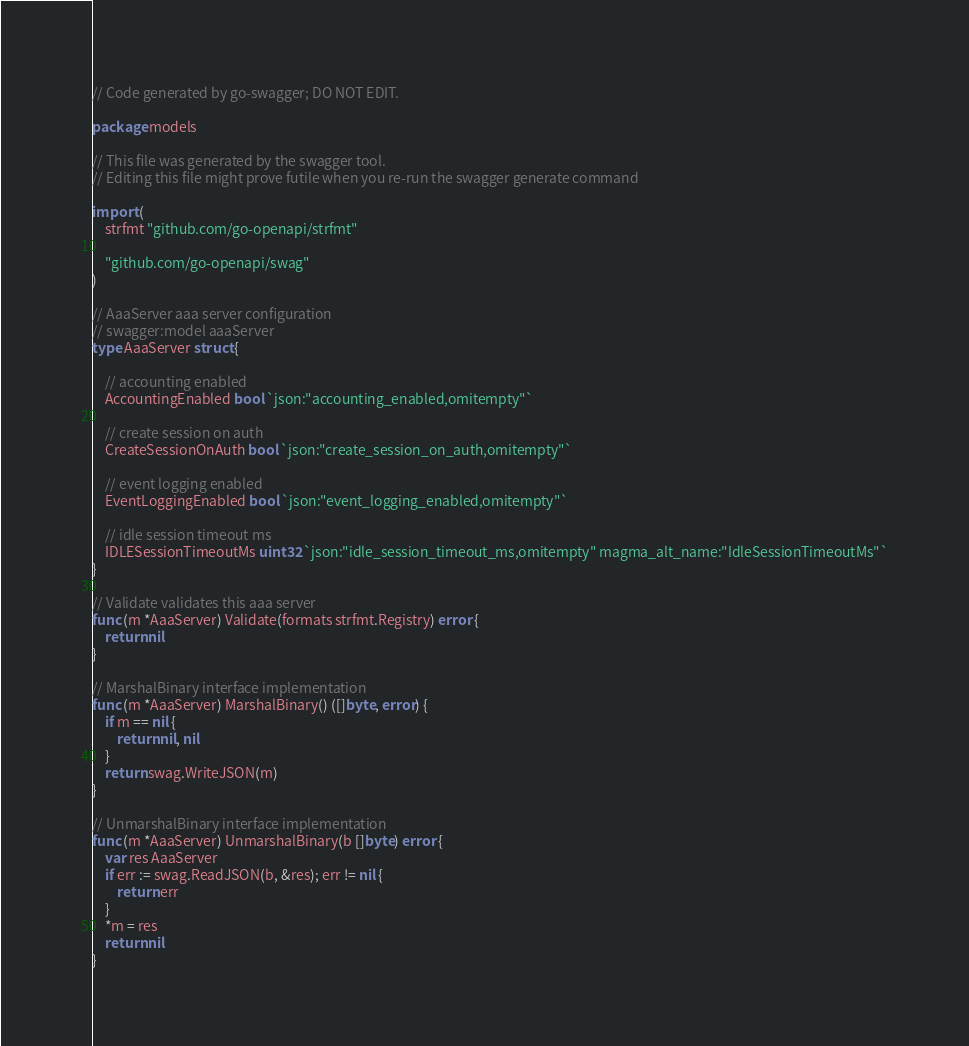Convert code to text. <code><loc_0><loc_0><loc_500><loc_500><_Go_>// Code generated by go-swagger; DO NOT EDIT.

package models

// This file was generated by the swagger tool.
// Editing this file might prove futile when you re-run the swagger generate command

import (
	strfmt "github.com/go-openapi/strfmt"

	"github.com/go-openapi/swag"
)

// AaaServer aaa server configuration
// swagger:model aaaServer
type AaaServer struct {

	// accounting enabled
	AccountingEnabled bool `json:"accounting_enabled,omitempty"`

	// create session on auth
	CreateSessionOnAuth bool `json:"create_session_on_auth,omitempty"`

	// event logging enabled
	EventLoggingEnabled bool `json:"event_logging_enabled,omitempty"`

	// idle session timeout ms
	IDLESessionTimeoutMs uint32 `json:"idle_session_timeout_ms,omitempty" magma_alt_name:"IdleSessionTimeoutMs"`
}

// Validate validates this aaa server
func (m *AaaServer) Validate(formats strfmt.Registry) error {
	return nil
}

// MarshalBinary interface implementation
func (m *AaaServer) MarshalBinary() ([]byte, error) {
	if m == nil {
		return nil, nil
	}
	return swag.WriteJSON(m)
}

// UnmarshalBinary interface implementation
func (m *AaaServer) UnmarshalBinary(b []byte) error {
	var res AaaServer
	if err := swag.ReadJSON(b, &res); err != nil {
		return err
	}
	*m = res
	return nil
}
</code> 